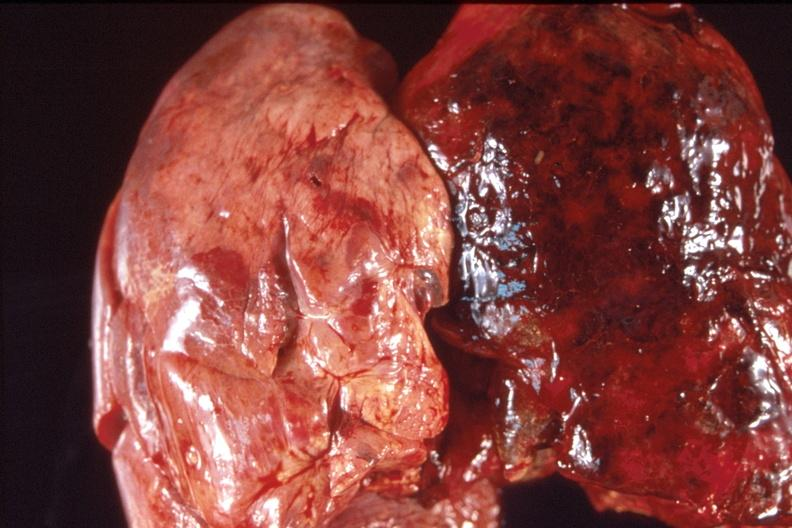does this image show lung, hemorrhagic fibrinous pleuritis?
Answer the question using a single word or phrase. Yes 